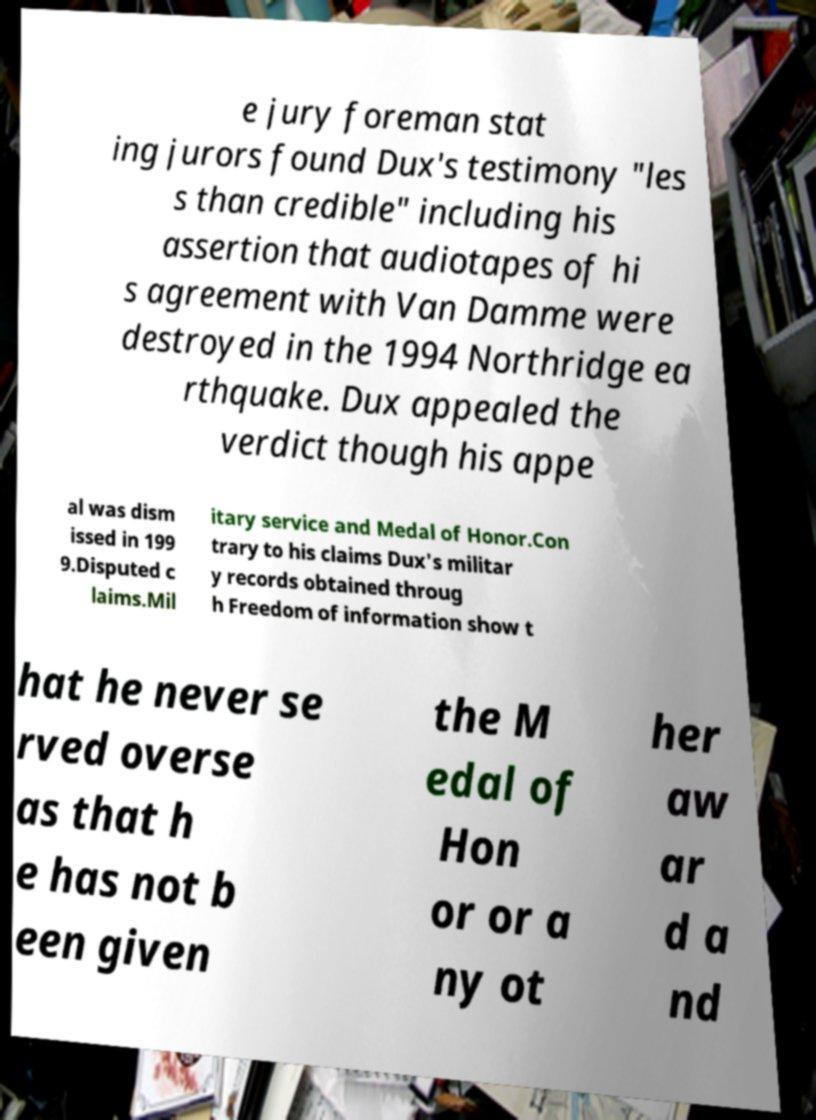Could you extract and type out the text from this image? e jury foreman stat ing jurors found Dux's testimony "les s than credible" including his assertion that audiotapes of hi s agreement with Van Damme were destroyed in the 1994 Northridge ea rthquake. Dux appealed the verdict though his appe al was dism issed in 199 9.Disputed c laims.Mil itary service and Medal of Honor.Con trary to his claims Dux's militar y records obtained throug h Freedom of information show t hat he never se rved overse as that h e has not b een given the M edal of Hon or or a ny ot her aw ar d a nd 